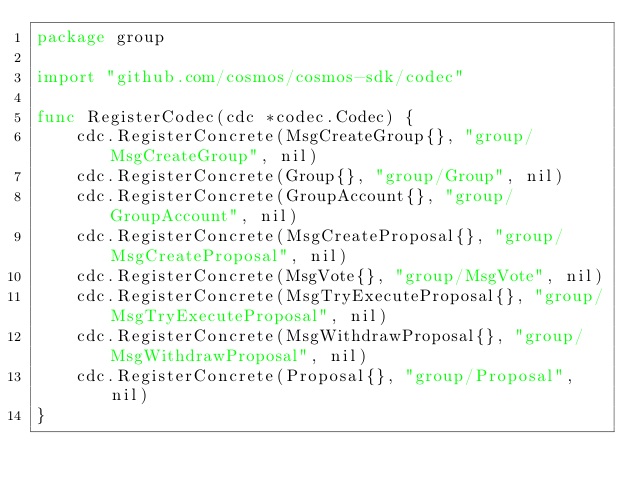<code> <loc_0><loc_0><loc_500><loc_500><_Go_>package group

import "github.com/cosmos/cosmos-sdk/codec"

func RegisterCodec(cdc *codec.Codec) {
	cdc.RegisterConcrete(MsgCreateGroup{}, "group/MsgCreateGroup", nil)
	cdc.RegisterConcrete(Group{}, "group/Group", nil)
	cdc.RegisterConcrete(GroupAccount{}, "group/GroupAccount", nil)
	cdc.RegisterConcrete(MsgCreateProposal{}, "group/MsgCreateProposal", nil)
	cdc.RegisterConcrete(MsgVote{}, "group/MsgVote", nil)
	cdc.RegisterConcrete(MsgTryExecuteProposal{}, "group/MsgTryExecuteProposal", nil)
	cdc.RegisterConcrete(MsgWithdrawProposal{}, "group/MsgWithdrawProposal", nil)
	cdc.RegisterConcrete(Proposal{}, "group/Proposal", nil)
}
</code> 